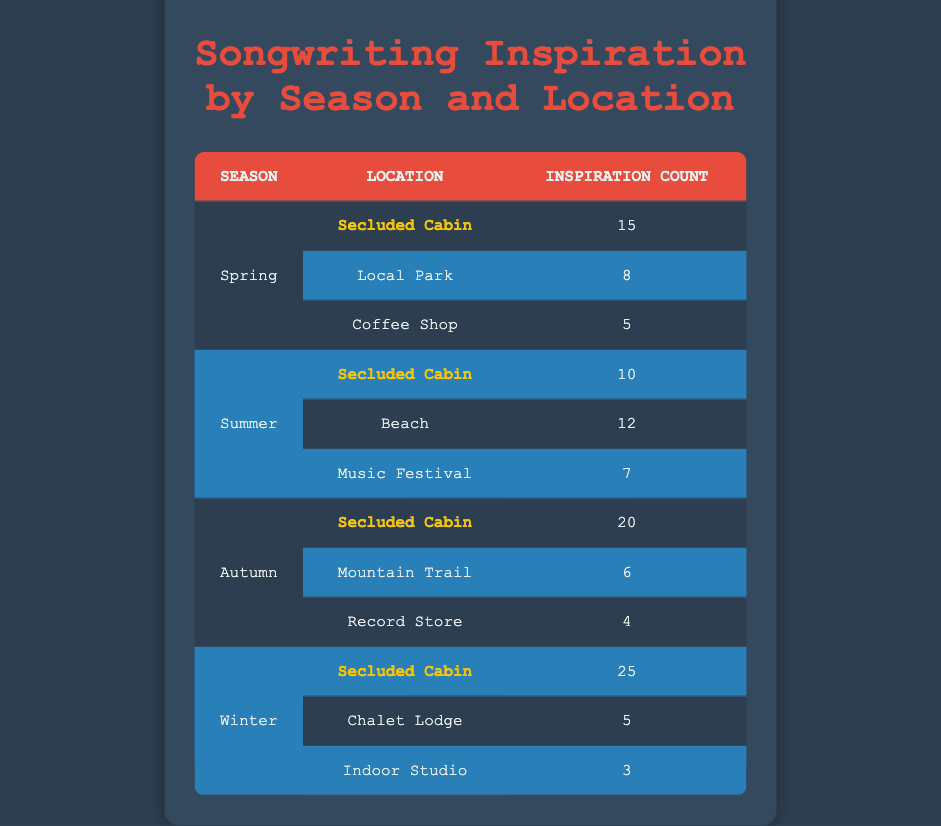What is the total inspiration count for the Secluded Cabin in Spring? Referring to the table, the total inspiration count for the Secluded Cabin in Spring is explicitly listed as 15.
Answer: 15 How many less inspirations were recorded in the Coffee Shop compared to the Local Park during Spring? The inspiration count for the Coffee Shop is 5, while for the Local Park it is 8. Therefore, 8 - 5 = 3 inspirations less in the Coffee Shop.
Answer: 3 What is the average inspiration count for all locations in Autumn? The inspiration counts for Autumn are 20 (Secluded Cabin), 6 (Mountain Trail), and 4 (Record Store). The sum is 20 + 6 + 4 = 30, and there are 3 locations, so the average is 30/3 = 10.
Answer: 10 Did the Secluded Cabin have more inspirations in Winter than in Summer? The Secluded Cabin inspiration counts are 25 in Winter and 10 in Summer. Since 25 > 10, the Secluded Cabin had more inspirations in Winter.
Answer: Yes What was the most inspirational location during Winter? In Winter, the Secluded Cabin had the highest inspiration count of 25, compared to 5 at the Chalet Lodge and 3 at the Indoor Studio. Therefore, the Secluded Cabin is the most inspirational location.
Answer: Secluded Cabin Which season had the highest total inspiration count? For each season: Spring is 28 (15 + 8 + 5), Summer is 29 (10 + 12 + 7), Autumn is 30 (20 + 6 + 4), and Winter is 33 (25 + 5 + 3). The highest total is from Winter with 33 inspirations.
Answer: Winter How many inspirations were recorded at the Beach in Summer? The table indicates the inspiration count for the Beach in Summer as 12.
Answer: 12 Is the inspiration count for the Chalet Lodge greater than that of the Mountain Trail in Autumn? The inspiration count for the Chalet Lodge is 5 (Winter), and for Mountain Trail (Autumn) is 6. Since 5 is not greater than 6, the statement is false.
Answer: No 